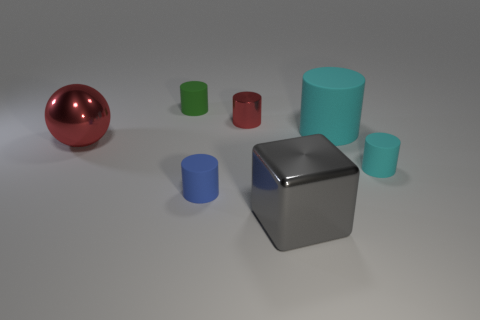What is the cylinder left of the blue cylinder made of?
Your answer should be compact. Rubber. What is the shape of the big object that is in front of the small rubber cylinder right of the red object that is behind the big cylinder?
Provide a short and direct response. Cube. Do the metallic cylinder and the sphere have the same size?
Your answer should be very brief. No. What number of objects are either small blue matte cylinders or big cyan rubber cylinders that are behind the large metal cube?
Ensure brevity in your answer.  2. What number of objects are objects right of the tiny blue thing or metallic objects that are right of the small green rubber object?
Give a very brief answer. 4. There is a small blue rubber cylinder; are there any blocks behind it?
Your answer should be compact. No. There is a matte object that is to the right of the cyan cylinder on the left side of the tiny object on the right side of the block; what color is it?
Make the answer very short. Cyan. Do the large cyan object and the small green thing have the same shape?
Provide a short and direct response. Yes. What is the color of the tiny cylinder that is made of the same material as the block?
Ensure brevity in your answer.  Red. How many objects are either matte cylinders that are in front of the tiny green object or red metal cylinders?
Your response must be concise. 4. 